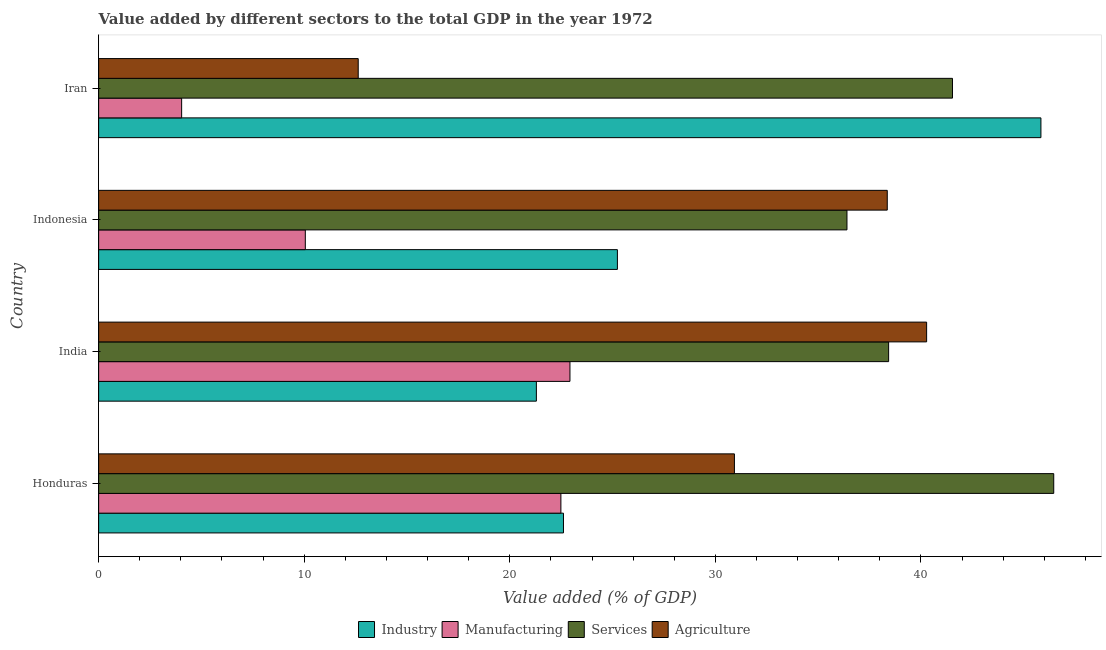How many different coloured bars are there?
Your answer should be very brief. 4. How many groups of bars are there?
Provide a succinct answer. 4. Are the number of bars per tick equal to the number of legend labels?
Give a very brief answer. Yes. Are the number of bars on each tick of the Y-axis equal?
Your answer should be very brief. Yes. How many bars are there on the 1st tick from the top?
Your answer should be compact. 4. In how many cases, is the number of bars for a given country not equal to the number of legend labels?
Your answer should be compact. 0. What is the value added by manufacturing sector in Indonesia?
Give a very brief answer. 10.05. Across all countries, what is the maximum value added by manufacturing sector?
Provide a succinct answer. 22.93. Across all countries, what is the minimum value added by agricultural sector?
Provide a short and direct response. 12.63. In which country was the value added by manufacturing sector maximum?
Provide a succinct answer. India. In which country was the value added by industrial sector minimum?
Keep it short and to the point. India. What is the total value added by agricultural sector in the graph?
Your answer should be very brief. 122.2. What is the difference between the value added by services sector in Honduras and that in Iran?
Your response must be concise. 4.92. What is the difference between the value added by agricultural sector in Honduras and the value added by industrial sector in Indonesia?
Provide a short and direct response. 5.69. What is the average value added by industrial sector per country?
Give a very brief answer. 28.75. What is the difference between the value added by manufacturing sector and value added by services sector in Honduras?
Provide a succinct answer. -23.97. What is the ratio of the value added by agricultural sector in Honduras to that in India?
Give a very brief answer. 0.77. Is the value added by services sector in Indonesia less than that in Iran?
Make the answer very short. Yes. What is the difference between the highest and the second highest value added by services sector?
Your response must be concise. 4.92. What is the difference between the highest and the lowest value added by manufacturing sector?
Your answer should be compact. 18.89. Is it the case that in every country, the sum of the value added by industrial sector and value added by services sector is greater than the sum of value added by manufacturing sector and value added by agricultural sector?
Ensure brevity in your answer.  Yes. What does the 2nd bar from the top in India represents?
Offer a terse response. Services. What does the 3rd bar from the bottom in Iran represents?
Provide a short and direct response. Services. Is it the case that in every country, the sum of the value added by industrial sector and value added by manufacturing sector is greater than the value added by services sector?
Offer a very short reply. No. How many countries are there in the graph?
Your answer should be compact. 4. Does the graph contain any zero values?
Provide a short and direct response. No. Where does the legend appear in the graph?
Your answer should be very brief. Bottom center. What is the title of the graph?
Keep it short and to the point. Value added by different sectors to the total GDP in the year 1972. Does "Iceland" appear as one of the legend labels in the graph?
Provide a short and direct response. No. What is the label or title of the X-axis?
Provide a short and direct response. Value added (% of GDP). What is the Value added (% of GDP) in Industry in Honduras?
Your response must be concise. 22.61. What is the Value added (% of GDP) in Manufacturing in Honduras?
Offer a terse response. 22.49. What is the Value added (% of GDP) in Services in Honduras?
Offer a terse response. 46.46. What is the Value added (% of GDP) in Agriculture in Honduras?
Your answer should be compact. 30.93. What is the Value added (% of GDP) of Industry in India?
Provide a succinct answer. 21.29. What is the Value added (% of GDP) in Manufacturing in India?
Give a very brief answer. 22.93. What is the Value added (% of GDP) in Services in India?
Provide a succinct answer. 38.43. What is the Value added (% of GDP) in Agriculture in India?
Your answer should be compact. 40.28. What is the Value added (% of GDP) in Industry in Indonesia?
Your answer should be compact. 25.24. What is the Value added (% of GDP) of Manufacturing in Indonesia?
Give a very brief answer. 10.05. What is the Value added (% of GDP) of Services in Indonesia?
Your response must be concise. 36.4. What is the Value added (% of GDP) of Agriculture in Indonesia?
Your answer should be compact. 38.36. What is the Value added (% of GDP) of Industry in Iran?
Your answer should be compact. 45.84. What is the Value added (% of GDP) of Manufacturing in Iran?
Give a very brief answer. 4.04. What is the Value added (% of GDP) in Services in Iran?
Ensure brevity in your answer.  41.54. What is the Value added (% of GDP) in Agriculture in Iran?
Your answer should be compact. 12.63. Across all countries, what is the maximum Value added (% of GDP) in Industry?
Your answer should be very brief. 45.84. Across all countries, what is the maximum Value added (% of GDP) in Manufacturing?
Make the answer very short. 22.93. Across all countries, what is the maximum Value added (% of GDP) of Services?
Provide a short and direct response. 46.46. Across all countries, what is the maximum Value added (% of GDP) of Agriculture?
Provide a succinct answer. 40.28. Across all countries, what is the minimum Value added (% of GDP) in Industry?
Your answer should be very brief. 21.29. Across all countries, what is the minimum Value added (% of GDP) of Manufacturing?
Your answer should be compact. 4.04. Across all countries, what is the minimum Value added (% of GDP) of Services?
Offer a terse response. 36.4. Across all countries, what is the minimum Value added (% of GDP) of Agriculture?
Keep it short and to the point. 12.63. What is the total Value added (% of GDP) in Industry in the graph?
Your answer should be very brief. 114.98. What is the total Value added (% of GDP) of Manufacturing in the graph?
Your answer should be compact. 59.5. What is the total Value added (% of GDP) of Services in the graph?
Your answer should be very brief. 162.83. What is the total Value added (% of GDP) of Agriculture in the graph?
Your answer should be compact. 122.2. What is the difference between the Value added (% of GDP) of Industry in Honduras and that in India?
Your answer should be compact. 1.32. What is the difference between the Value added (% of GDP) of Manufacturing in Honduras and that in India?
Offer a very short reply. -0.44. What is the difference between the Value added (% of GDP) of Services in Honduras and that in India?
Give a very brief answer. 8.03. What is the difference between the Value added (% of GDP) in Agriculture in Honduras and that in India?
Your response must be concise. -9.35. What is the difference between the Value added (% of GDP) of Industry in Honduras and that in Indonesia?
Provide a succinct answer. -2.62. What is the difference between the Value added (% of GDP) in Manufacturing in Honduras and that in Indonesia?
Keep it short and to the point. 12.43. What is the difference between the Value added (% of GDP) of Services in Honduras and that in Indonesia?
Keep it short and to the point. 10.06. What is the difference between the Value added (% of GDP) in Agriculture in Honduras and that in Indonesia?
Your answer should be very brief. -7.44. What is the difference between the Value added (% of GDP) of Industry in Honduras and that in Iran?
Ensure brevity in your answer.  -23.23. What is the difference between the Value added (% of GDP) in Manufacturing in Honduras and that in Iran?
Ensure brevity in your answer.  18.45. What is the difference between the Value added (% of GDP) of Services in Honduras and that in Iran?
Offer a terse response. 4.93. What is the difference between the Value added (% of GDP) of Agriculture in Honduras and that in Iran?
Provide a short and direct response. 18.3. What is the difference between the Value added (% of GDP) in Industry in India and that in Indonesia?
Ensure brevity in your answer.  -3.94. What is the difference between the Value added (% of GDP) in Manufacturing in India and that in Indonesia?
Your response must be concise. 12.87. What is the difference between the Value added (% of GDP) in Services in India and that in Indonesia?
Give a very brief answer. 2.03. What is the difference between the Value added (% of GDP) of Agriculture in India and that in Indonesia?
Your answer should be very brief. 1.91. What is the difference between the Value added (% of GDP) in Industry in India and that in Iran?
Provide a succinct answer. -24.54. What is the difference between the Value added (% of GDP) in Manufacturing in India and that in Iran?
Keep it short and to the point. 18.89. What is the difference between the Value added (% of GDP) of Services in India and that in Iran?
Provide a short and direct response. -3.11. What is the difference between the Value added (% of GDP) of Agriculture in India and that in Iran?
Your response must be concise. 27.65. What is the difference between the Value added (% of GDP) of Industry in Indonesia and that in Iran?
Keep it short and to the point. -20.6. What is the difference between the Value added (% of GDP) of Manufacturing in Indonesia and that in Iran?
Provide a short and direct response. 6.02. What is the difference between the Value added (% of GDP) in Services in Indonesia and that in Iran?
Your response must be concise. -5.13. What is the difference between the Value added (% of GDP) of Agriculture in Indonesia and that in Iran?
Your response must be concise. 25.74. What is the difference between the Value added (% of GDP) of Industry in Honduras and the Value added (% of GDP) of Manufacturing in India?
Keep it short and to the point. -0.32. What is the difference between the Value added (% of GDP) in Industry in Honduras and the Value added (% of GDP) in Services in India?
Your answer should be compact. -15.82. What is the difference between the Value added (% of GDP) of Industry in Honduras and the Value added (% of GDP) of Agriculture in India?
Your answer should be compact. -17.67. What is the difference between the Value added (% of GDP) of Manufacturing in Honduras and the Value added (% of GDP) of Services in India?
Your answer should be compact. -15.94. What is the difference between the Value added (% of GDP) in Manufacturing in Honduras and the Value added (% of GDP) in Agriculture in India?
Offer a very short reply. -17.79. What is the difference between the Value added (% of GDP) in Services in Honduras and the Value added (% of GDP) in Agriculture in India?
Your answer should be very brief. 6.18. What is the difference between the Value added (% of GDP) in Industry in Honduras and the Value added (% of GDP) in Manufacturing in Indonesia?
Offer a very short reply. 12.56. What is the difference between the Value added (% of GDP) of Industry in Honduras and the Value added (% of GDP) of Services in Indonesia?
Give a very brief answer. -13.79. What is the difference between the Value added (% of GDP) in Industry in Honduras and the Value added (% of GDP) in Agriculture in Indonesia?
Your answer should be very brief. -15.75. What is the difference between the Value added (% of GDP) in Manufacturing in Honduras and the Value added (% of GDP) in Services in Indonesia?
Ensure brevity in your answer.  -13.92. What is the difference between the Value added (% of GDP) of Manufacturing in Honduras and the Value added (% of GDP) of Agriculture in Indonesia?
Keep it short and to the point. -15.88. What is the difference between the Value added (% of GDP) of Services in Honduras and the Value added (% of GDP) of Agriculture in Indonesia?
Ensure brevity in your answer.  8.1. What is the difference between the Value added (% of GDP) in Industry in Honduras and the Value added (% of GDP) in Manufacturing in Iran?
Make the answer very short. 18.57. What is the difference between the Value added (% of GDP) of Industry in Honduras and the Value added (% of GDP) of Services in Iran?
Ensure brevity in your answer.  -18.92. What is the difference between the Value added (% of GDP) of Industry in Honduras and the Value added (% of GDP) of Agriculture in Iran?
Offer a very short reply. 9.98. What is the difference between the Value added (% of GDP) in Manufacturing in Honduras and the Value added (% of GDP) in Services in Iran?
Your answer should be compact. -19.05. What is the difference between the Value added (% of GDP) of Manufacturing in Honduras and the Value added (% of GDP) of Agriculture in Iran?
Provide a succinct answer. 9.86. What is the difference between the Value added (% of GDP) in Services in Honduras and the Value added (% of GDP) in Agriculture in Iran?
Offer a terse response. 33.83. What is the difference between the Value added (% of GDP) in Industry in India and the Value added (% of GDP) in Manufacturing in Indonesia?
Your answer should be compact. 11.24. What is the difference between the Value added (% of GDP) in Industry in India and the Value added (% of GDP) in Services in Indonesia?
Your answer should be compact. -15.11. What is the difference between the Value added (% of GDP) in Industry in India and the Value added (% of GDP) in Agriculture in Indonesia?
Offer a very short reply. -17.07. What is the difference between the Value added (% of GDP) of Manufacturing in India and the Value added (% of GDP) of Services in Indonesia?
Ensure brevity in your answer.  -13.48. What is the difference between the Value added (% of GDP) in Manufacturing in India and the Value added (% of GDP) in Agriculture in Indonesia?
Provide a short and direct response. -15.44. What is the difference between the Value added (% of GDP) in Services in India and the Value added (% of GDP) in Agriculture in Indonesia?
Keep it short and to the point. 0.07. What is the difference between the Value added (% of GDP) of Industry in India and the Value added (% of GDP) of Manufacturing in Iran?
Provide a succinct answer. 17.26. What is the difference between the Value added (% of GDP) of Industry in India and the Value added (% of GDP) of Services in Iran?
Provide a succinct answer. -20.24. What is the difference between the Value added (% of GDP) in Industry in India and the Value added (% of GDP) in Agriculture in Iran?
Make the answer very short. 8.67. What is the difference between the Value added (% of GDP) in Manufacturing in India and the Value added (% of GDP) in Services in Iran?
Ensure brevity in your answer.  -18.61. What is the difference between the Value added (% of GDP) of Manufacturing in India and the Value added (% of GDP) of Agriculture in Iran?
Your answer should be very brief. 10.3. What is the difference between the Value added (% of GDP) of Services in India and the Value added (% of GDP) of Agriculture in Iran?
Provide a short and direct response. 25.8. What is the difference between the Value added (% of GDP) of Industry in Indonesia and the Value added (% of GDP) of Manufacturing in Iran?
Offer a terse response. 21.2. What is the difference between the Value added (% of GDP) in Industry in Indonesia and the Value added (% of GDP) in Services in Iran?
Provide a short and direct response. -16.3. What is the difference between the Value added (% of GDP) in Industry in Indonesia and the Value added (% of GDP) in Agriculture in Iran?
Offer a very short reply. 12.61. What is the difference between the Value added (% of GDP) of Manufacturing in Indonesia and the Value added (% of GDP) of Services in Iran?
Keep it short and to the point. -31.48. What is the difference between the Value added (% of GDP) in Manufacturing in Indonesia and the Value added (% of GDP) in Agriculture in Iran?
Provide a short and direct response. -2.57. What is the difference between the Value added (% of GDP) in Services in Indonesia and the Value added (% of GDP) in Agriculture in Iran?
Offer a very short reply. 23.77. What is the average Value added (% of GDP) of Industry per country?
Offer a very short reply. 28.74. What is the average Value added (% of GDP) of Manufacturing per country?
Your answer should be very brief. 14.88. What is the average Value added (% of GDP) in Services per country?
Provide a succinct answer. 40.71. What is the average Value added (% of GDP) of Agriculture per country?
Keep it short and to the point. 30.55. What is the difference between the Value added (% of GDP) of Industry and Value added (% of GDP) of Manufacturing in Honduras?
Make the answer very short. 0.13. What is the difference between the Value added (% of GDP) of Industry and Value added (% of GDP) of Services in Honduras?
Your answer should be very brief. -23.85. What is the difference between the Value added (% of GDP) in Industry and Value added (% of GDP) in Agriculture in Honduras?
Ensure brevity in your answer.  -8.32. What is the difference between the Value added (% of GDP) of Manufacturing and Value added (% of GDP) of Services in Honduras?
Offer a very short reply. -23.97. What is the difference between the Value added (% of GDP) in Manufacturing and Value added (% of GDP) in Agriculture in Honduras?
Provide a succinct answer. -8.44. What is the difference between the Value added (% of GDP) of Services and Value added (% of GDP) of Agriculture in Honduras?
Provide a succinct answer. 15.53. What is the difference between the Value added (% of GDP) in Industry and Value added (% of GDP) in Manufacturing in India?
Make the answer very short. -1.63. What is the difference between the Value added (% of GDP) of Industry and Value added (% of GDP) of Services in India?
Make the answer very short. -17.13. What is the difference between the Value added (% of GDP) in Industry and Value added (% of GDP) in Agriculture in India?
Offer a very short reply. -18.98. What is the difference between the Value added (% of GDP) of Manufacturing and Value added (% of GDP) of Services in India?
Your answer should be very brief. -15.5. What is the difference between the Value added (% of GDP) of Manufacturing and Value added (% of GDP) of Agriculture in India?
Give a very brief answer. -17.35. What is the difference between the Value added (% of GDP) in Services and Value added (% of GDP) in Agriculture in India?
Make the answer very short. -1.85. What is the difference between the Value added (% of GDP) in Industry and Value added (% of GDP) in Manufacturing in Indonesia?
Keep it short and to the point. 15.18. What is the difference between the Value added (% of GDP) of Industry and Value added (% of GDP) of Services in Indonesia?
Provide a succinct answer. -11.17. What is the difference between the Value added (% of GDP) in Industry and Value added (% of GDP) in Agriculture in Indonesia?
Provide a succinct answer. -13.13. What is the difference between the Value added (% of GDP) of Manufacturing and Value added (% of GDP) of Services in Indonesia?
Provide a short and direct response. -26.35. What is the difference between the Value added (% of GDP) in Manufacturing and Value added (% of GDP) in Agriculture in Indonesia?
Your response must be concise. -28.31. What is the difference between the Value added (% of GDP) in Services and Value added (% of GDP) in Agriculture in Indonesia?
Give a very brief answer. -1.96. What is the difference between the Value added (% of GDP) of Industry and Value added (% of GDP) of Manufacturing in Iran?
Your response must be concise. 41.8. What is the difference between the Value added (% of GDP) of Industry and Value added (% of GDP) of Services in Iran?
Ensure brevity in your answer.  4.3. What is the difference between the Value added (% of GDP) of Industry and Value added (% of GDP) of Agriculture in Iran?
Offer a very short reply. 33.21. What is the difference between the Value added (% of GDP) of Manufacturing and Value added (% of GDP) of Services in Iran?
Your answer should be compact. -37.5. What is the difference between the Value added (% of GDP) in Manufacturing and Value added (% of GDP) in Agriculture in Iran?
Keep it short and to the point. -8.59. What is the difference between the Value added (% of GDP) in Services and Value added (% of GDP) in Agriculture in Iran?
Offer a terse response. 28.91. What is the ratio of the Value added (% of GDP) of Industry in Honduras to that in India?
Ensure brevity in your answer.  1.06. What is the ratio of the Value added (% of GDP) in Manufacturing in Honduras to that in India?
Provide a succinct answer. 0.98. What is the ratio of the Value added (% of GDP) in Services in Honduras to that in India?
Your answer should be compact. 1.21. What is the ratio of the Value added (% of GDP) in Agriculture in Honduras to that in India?
Offer a very short reply. 0.77. What is the ratio of the Value added (% of GDP) of Industry in Honduras to that in Indonesia?
Your answer should be compact. 0.9. What is the ratio of the Value added (% of GDP) of Manufacturing in Honduras to that in Indonesia?
Ensure brevity in your answer.  2.24. What is the ratio of the Value added (% of GDP) of Services in Honduras to that in Indonesia?
Your answer should be compact. 1.28. What is the ratio of the Value added (% of GDP) in Agriculture in Honduras to that in Indonesia?
Offer a very short reply. 0.81. What is the ratio of the Value added (% of GDP) in Industry in Honduras to that in Iran?
Provide a succinct answer. 0.49. What is the ratio of the Value added (% of GDP) of Manufacturing in Honduras to that in Iran?
Your answer should be very brief. 5.57. What is the ratio of the Value added (% of GDP) of Services in Honduras to that in Iran?
Your response must be concise. 1.12. What is the ratio of the Value added (% of GDP) of Agriculture in Honduras to that in Iran?
Give a very brief answer. 2.45. What is the ratio of the Value added (% of GDP) of Industry in India to that in Indonesia?
Ensure brevity in your answer.  0.84. What is the ratio of the Value added (% of GDP) of Manufacturing in India to that in Indonesia?
Offer a terse response. 2.28. What is the ratio of the Value added (% of GDP) in Services in India to that in Indonesia?
Your answer should be compact. 1.06. What is the ratio of the Value added (% of GDP) in Agriculture in India to that in Indonesia?
Make the answer very short. 1.05. What is the ratio of the Value added (% of GDP) in Industry in India to that in Iran?
Your answer should be very brief. 0.46. What is the ratio of the Value added (% of GDP) of Manufacturing in India to that in Iran?
Provide a short and direct response. 5.68. What is the ratio of the Value added (% of GDP) in Services in India to that in Iran?
Your answer should be compact. 0.93. What is the ratio of the Value added (% of GDP) of Agriculture in India to that in Iran?
Make the answer very short. 3.19. What is the ratio of the Value added (% of GDP) in Industry in Indonesia to that in Iran?
Provide a short and direct response. 0.55. What is the ratio of the Value added (% of GDP) of Manufacturing in Indonesia to that in Iran?
Give a very brief answer. 2.49. What is the ratio of the Value added (% of GDP) in Services in Indonesia to that in Iran?
Provide a short and direct response. 0.88. What is the ratio of the Value added (% of GDP) of Agriculture in Indonesia to that in Iran?
Give a very brief answer. 3.04. What is the difference between the highest and the second highest Value added (% of GDP) of Industry?
Your response must be concise. 20.6. What is the difference between the highest and the second highest Value added (% of GDP) in Manufacturing?
Offer a very short reply. 0.44. What is the difference between the highest and the second highest Value added (% of GDP) of Services?
Your answer should be very brief. 4.93. What is the difference between the highest and the second highest Value added (% of GDP) of Agriculture?
Give a very brief answer. 1.91. What is the difference between the highest and the lowest Value added (% of GDP) in Industry?
Ensure brevity in your answer.  24.54. What is the difference between the highest and the lowest Value added (% of GDP) of Manufacturing?
Ensure brevity in your answer.  18.89. What is the difference between the highest and the lowest Value added (% of GDP) in Services?
Provide a succinct answer. 10.06. What is the difference between the highest and the lowest Value added (% of GDP) in Agriculture?
Offer a terse response. 27.65. 